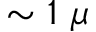<formula> <loc_0><loc_0><loc_500><loc_500>\sim 1 \mu</formula> 